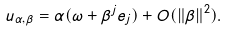<formula> <loc_0><loc_0><loc_500><loc_500>u _ { \alpha , \beta } = \alpha ( \omega + \beta ^ { j } e _ { j } ) + O ( \| \beta \| ^ { 2 } ) .</formula> 